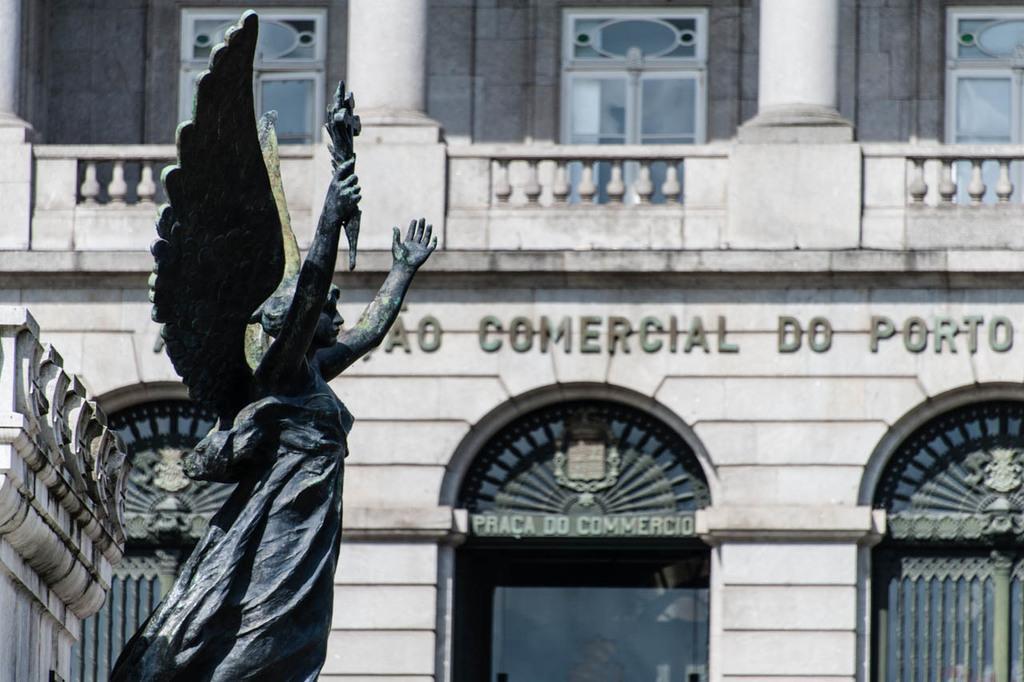How would you summarize this image in a sentence or two? In the foreground of the image we can see a statue. In the background of the image we can see a building with windows, poles and some text on it 